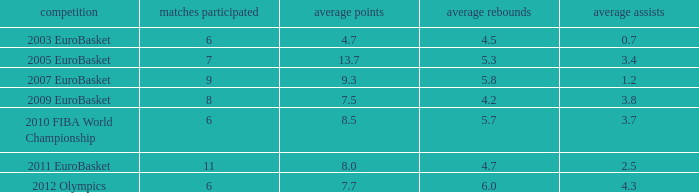How many games played have 4.7 as points per game? 6.0. 